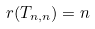<formula> <loc_0><loc_0><loc_500><loc_500>r ( T _ { n , n } ) = n</formula> 